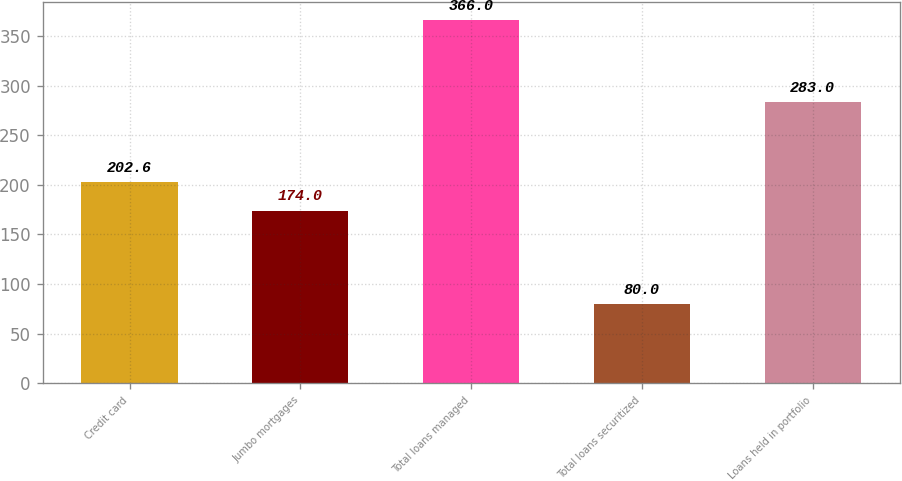<chart> <loc_0><loc_0><loc_500><loc_500><bar_chart><fcel>Credit card<fcel>Jumbo mortgages<fcel>Total loans managed<fcel>Total loans securitized<fcel>Loans held in portfolio<nl><fcel>202.6<fcel>174<fcel>366<fcel>80<fcel>283<nl></chart> 